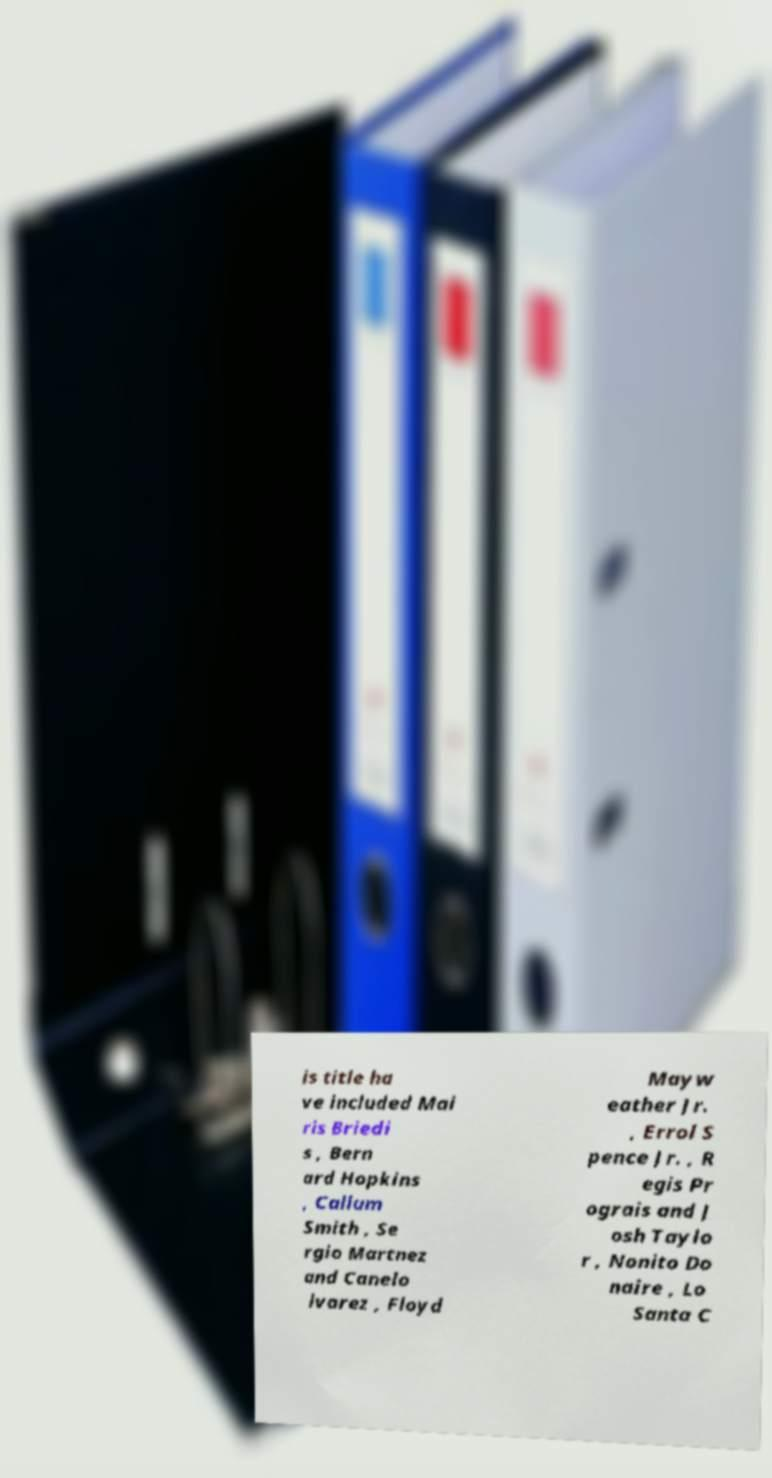For documentation purposes, I need the text within this image transcribed. Could you provide that? is title ha ve included Mai ris Briedi s , Bern ard Hopkins , Callum Smith , Se rgio Martnez and Canelo lvarez , Floyd Mayw eather Jr. , Errol S pence Jr. , R egis Pr ograis and J osh Taylo r , Nonito Do naire , Lo Santa C 